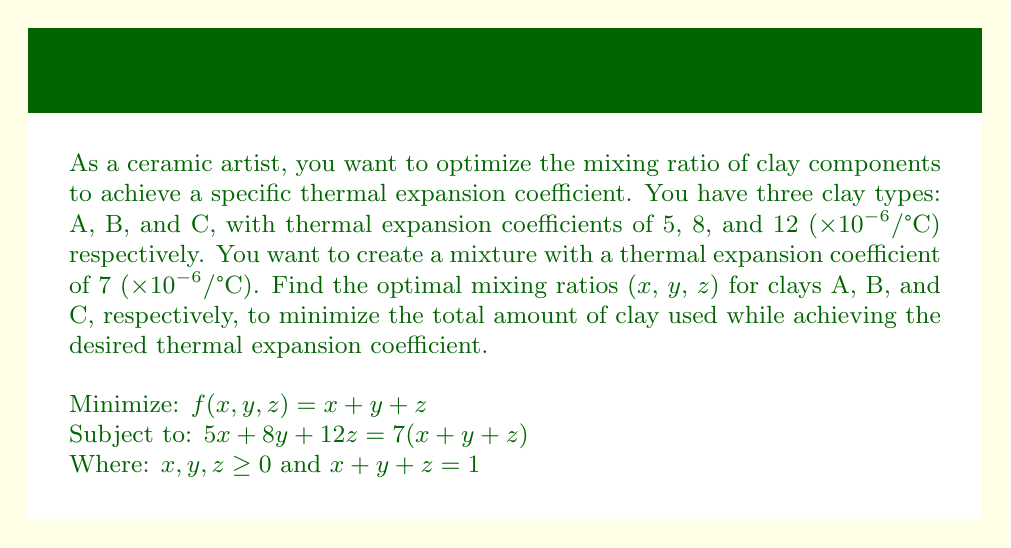Teach me how to tackle this problem. Let's solve this optimization problem step by step:

1) We have three constraints:
   a) $5x + 8y + 12z = 7(x + y + z)$
   b) $x + y + z = 1$
   c) $x, y, z \geq 0$

2) From constraint (a), we can simplify:
   $5x + 8y + 12z = 7x + 7y + 7z$
   $-2x + y + 5z = 0$

3) We now have two equations:
   $-2x + y + 5z = 0$
   $x + y + z = 1$

4) We can solve this system of equations. From the second equation:
   $y = 1 - x - z$

5) Substituting this into the first equation:
   $-2x + (1 - x - z) + 5z = 0$
   $-2x + 1 - x - z + 5z = 0$
   $-3x + 4z = -1$
   $3x - 4z = 1$

6) Now we have:
   $3x - 4z = 1$
   $x + y + z = 1$

7) From the first equation:
   $x = \frac{1 + 4z}{3}$

8) Substituting this into $x + y + z = 1$:
   $\frac{1 + 4z}{3} + y + z = 1$

9) Solving for y:
   $y = 1 - \frac{1 + 4z}{3} - z = \frac{2 - 5z}{3}$

10) Now we have expressions for x, y, and z:
    $x = \frac{1 + 4z}{3}$
    $y = \frac{2 - 5z}{3}$
    $z = z$

11) Since we want to minimize the total amount of clay used, and $x + y + z = 1$, any solution satisfying our constraints will be optimal.

12) We need to ensure $x, y, z \geq 0$:
    $\frac{1 + 4z}{3} \geq 0$ implies $z \geq -\frac{1}{4}$
    $\frac{2 - 5z}{3} \geq 0$ implies $z \leq \frac{2}{5}$

13) Therefore, $z$ can be any value between 0 and $\frac{2}{5}$.

14) Let's choose $z = \frac{1}{5}$ for simplicity:
    $x = \frac{1 + 4(\frac{1}{5})}{3} = \frac{3}{5}$
    $y = \frac{2 - 5(\frac{1}{5})}{3} = \frac{1}{5}$
    $z = \frac{1}{5}$
Answer: $x = \frac{3}{5}$, $y = \frac{1}{5}$, $z = \frac{1}{5}$ 